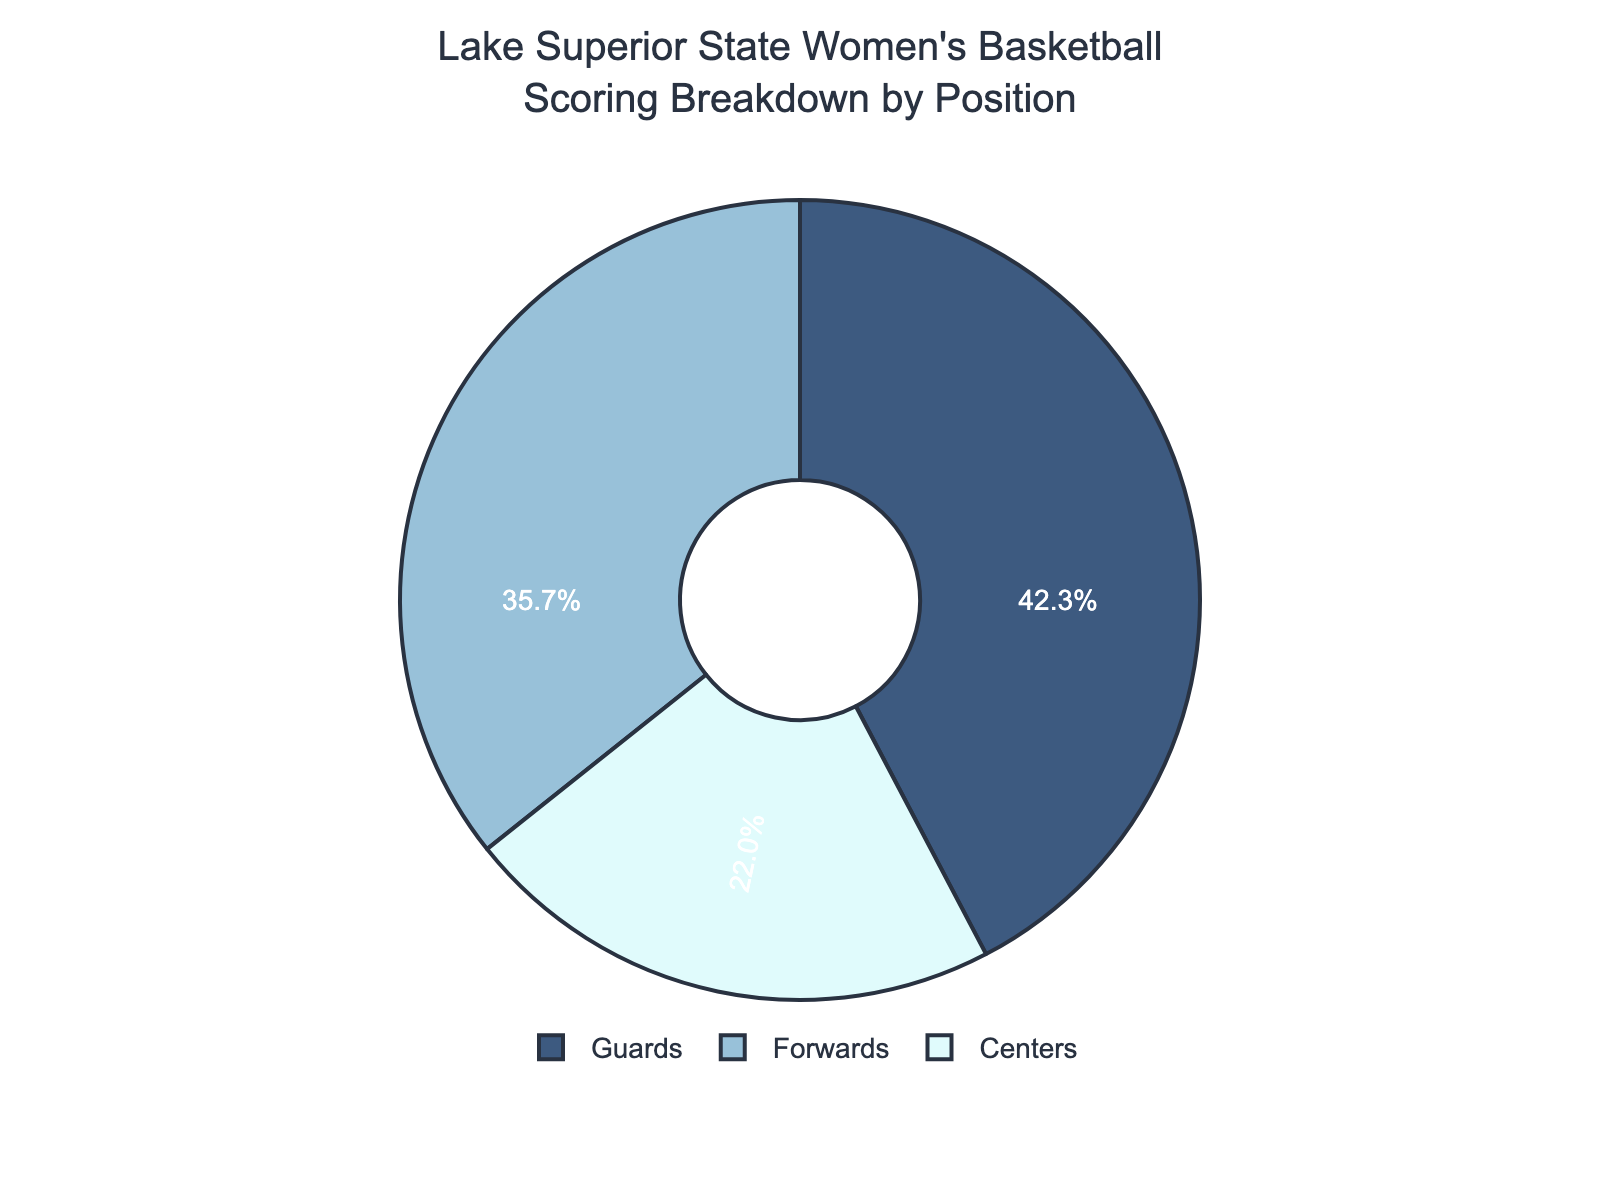What's the percentage contribution of guards to the total scoring? The pie chart shows that guards contribute 42.3% to the total scoring of the team.
Answer: 42.3% How much greater is the scoring contribution of guards compared to centers? The guards contribute 42.3% while the centers contribute 22%. The difference can be calculated as 42.3% - 22% = 20.3%.
Answer: 20.3% Which position contributes the least to the total scoring? From the pie chart, centers have the smallest percentage contribution, which is 22%.
Answer: Centers What is the combined percentage contribution of guards and forwards? The pie chart indicates guards contribute 42.3%, and forwards contribute 35.7%. Summing these gives 42.3% + 35.7% = 78%.
Answer: 78% Are the combined scoring contributions of forwards and centers more than the contributions of guards? Forwards (35.7%) and centers (22%) together contribute 57.7%, whereas guards contribute 42.3%. The combined contribution of forwards and centers is greater: 57.7% > 42.3%.
Answer: Yes How much more do forwards contribute than centers? Forwards contribute 35.7% and centers contribute 22%. The difference is 35.7% - 22% = 13.7%.
Answer: 13.7% Which position's scoring percentage is closest to 40%? Among the listed percentages, the guards' contribution of 42.3% is closest to 40%.
Answer: Guards What percentage of the total scoring is contributed by positions other than guards? The guards contribute 42.3%, so other positions contribute 100% - 42.3% = 57.7%.
Answer: 57.7% How much does the total contribution of forwards and centers differ from 60%? Forwards and centers combine to contribute 35.7% + 22% = 57.7%. The difference from 60% is 60% - 57.7% = 2.3%.
Answer: 2.3% 